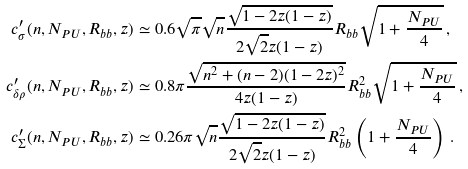Convert formula to latex. <formula><loc_0><loc_0><loc_500><loc_500>c _ { \sigma } ^ { \prime } ( n , N _ { P U } , R _ { b b } , z ) & \simeq 0 . 6 \sqrt { \pi } \sqrt { n } \frac { \sqrt { 1 - 2 z ( 1 - z ) } } { 2 \sqrt { 2 } z ( 1 - z ) } R _ { b b } \sqrt { 1 + \frac { N _ { P U } } { 4 } } \, , \\ c _ { \delta \rho } ^ { \prime } ( n , N _ { P U } , R _ { b b } , z ) & \simeq 0 . 8 \pi \frac { \sqrt { n ^ { 2 } + ( n - 2 ) ( 1 - 2 z ) ^ { 2 } } } { 4 z ( 1 - z ) } R _ { b b } ^ { 2 } \sqrt { 1 + \frac { N _ { P U } } { 4 } } \, , \\ c _ { \Sigma } ^ { \prime } ( n , N _ { P U } , R _ { b b } , z ) & \simeq 0 . 2 6 \pi \sqrt { n } \frac { \sqrt { 1 - 2 z ( 1 - z ) } } { 2 \sqrt { 2 } z ( 1 - z ) } R _ { b b } ^ { 2 } \left ( 1 + \frac { N _ { P U } } { 4 } \right ) \, .</formula> 